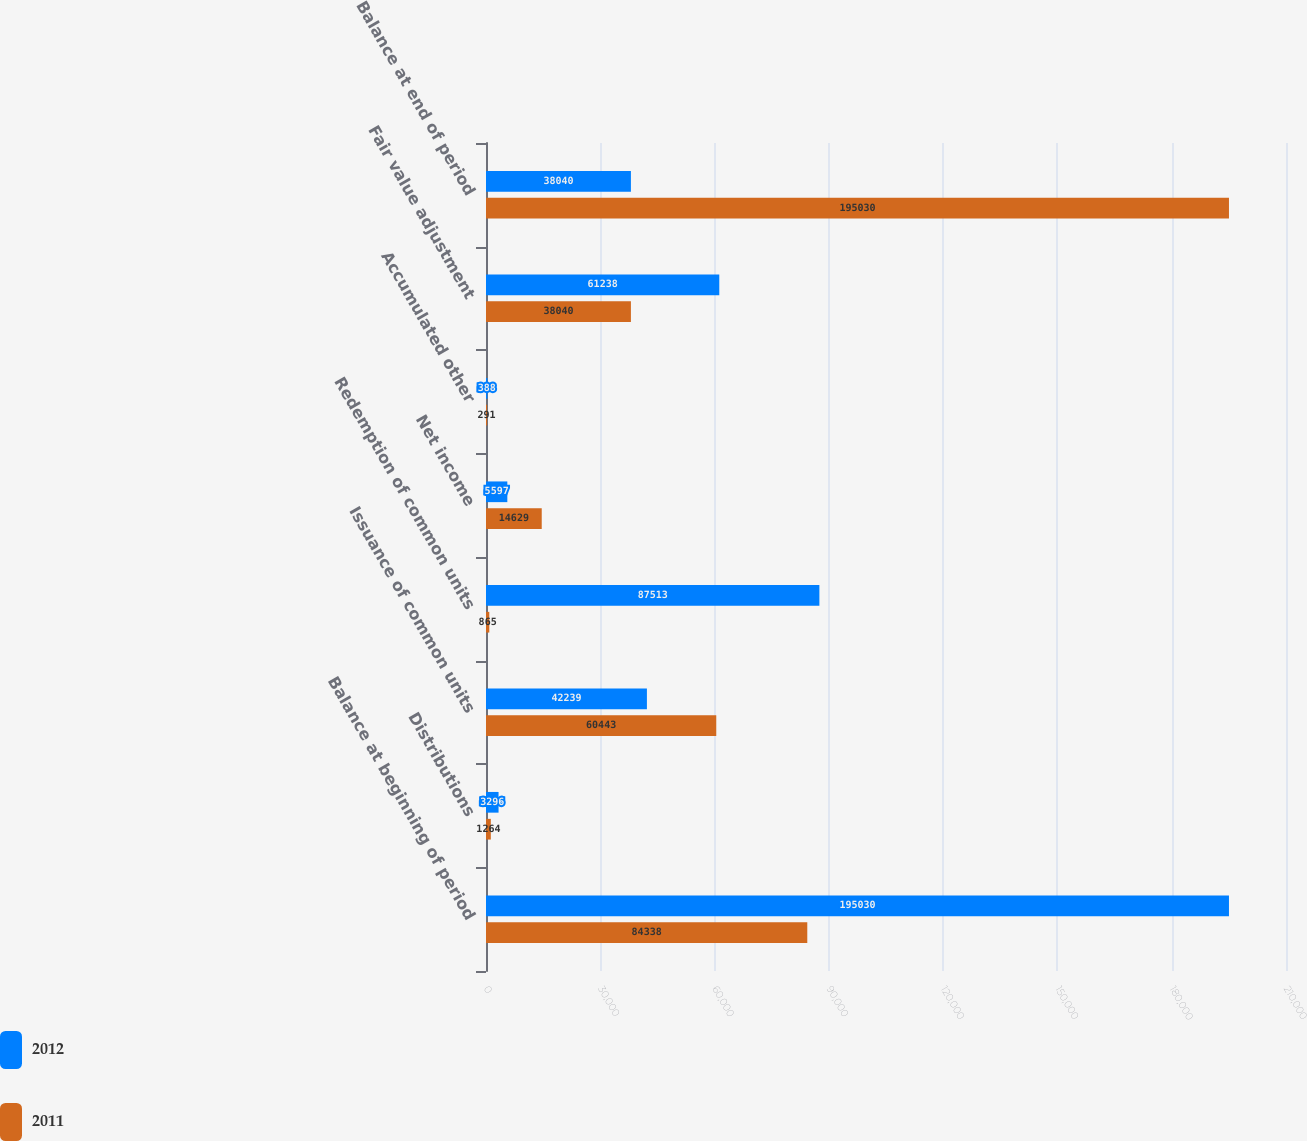Convert chart. <chart><loc_0><loc_0><loc_500><loc_500><stacked_bar_chart><ecel><fcel>Balance at beginning of period<fcel>Distributions<fcel>Issuance of common units<fcel>Redemption of common units<fcel>Net income<fcel>Accumulated other<fcel>Fair value adjustment<fcel>Balance at end of period<nl><fcel>2012<fcel>195030<fcel>3296<fcel>42239<fcel>87513<fcel>5597<fcel>388<fcel>61238<fcel>38040<nl><fcel>2011<fcel>84338<fcel>1264<fcel>60443<fcel>865<fcel>14629<fcel>291<fcel>38040<fcel>195030<nl></chart> 